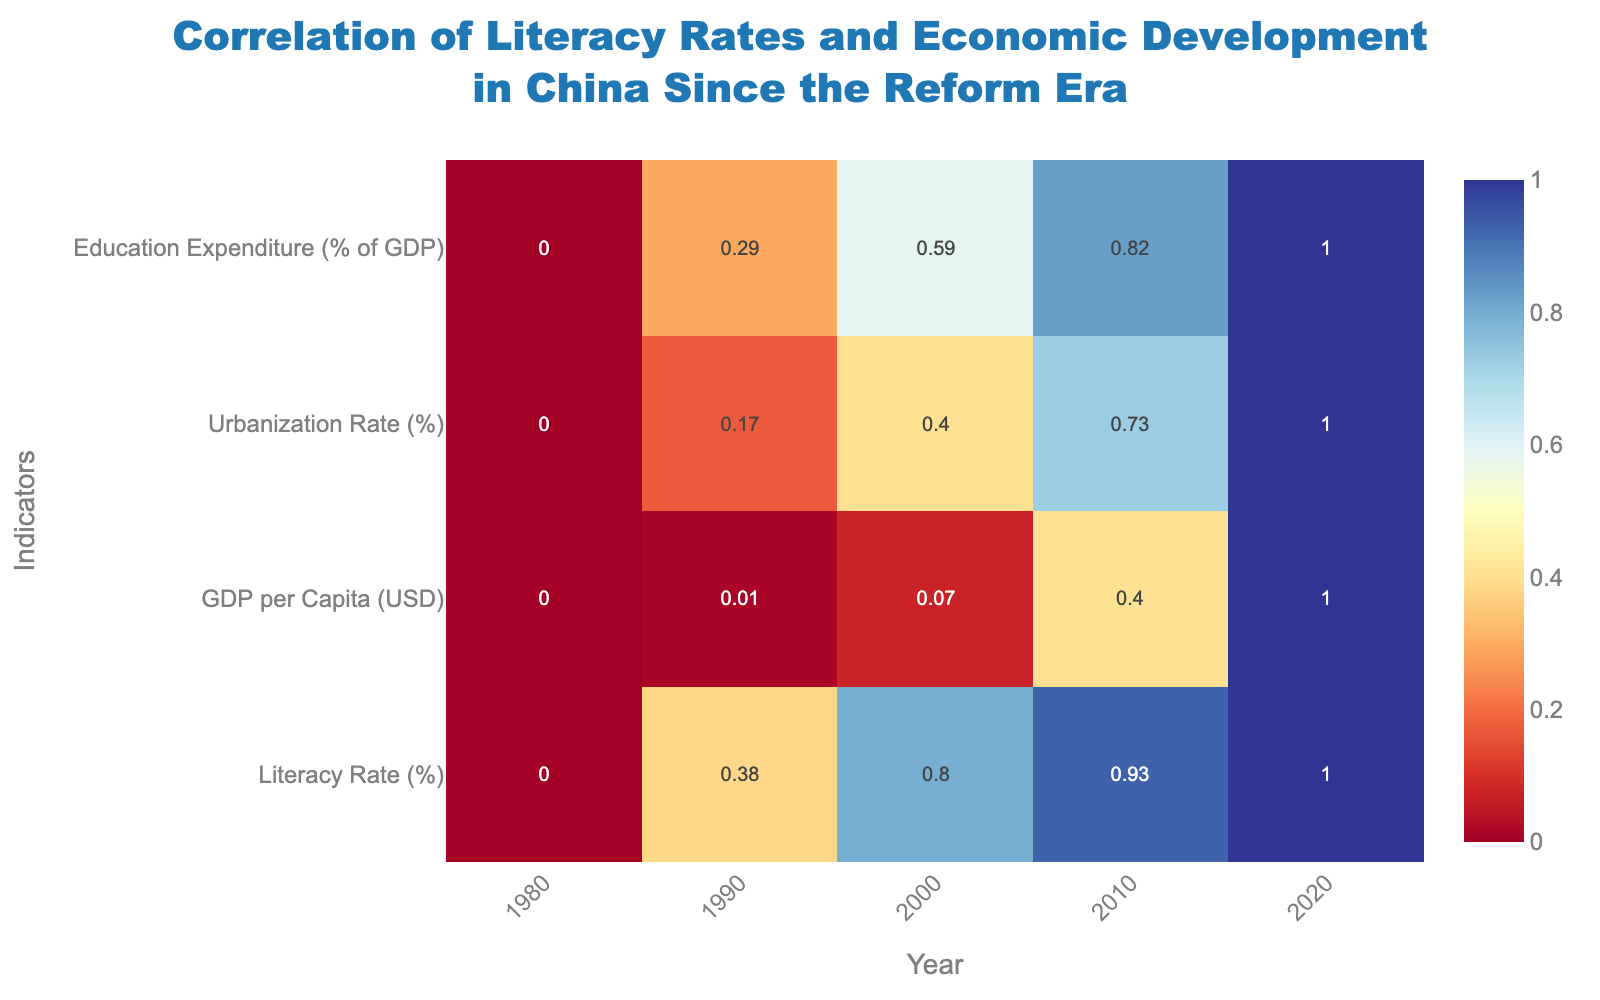what is the main title of the heatmap? Look at the top portion of the heatmap where titles are generally placed. The main title reads, "Correlation of Literacy Rates and Economic Development in China Since the Reform Era".
Answer: Correlation of Literacy Rates and Economic Development in China Since the Reform Era What are the indicators shown on the y-axis? Examine the y-axis to determine which variables are listed. The y-axis indicators are Literacy Rate (%), GDP per Capita (USD), Urbanization Rate (%), and Education Expenditure (% of GDP).
Answer: Literacy Rate (%), GDP per Capita (USD), Urbanization Rate (%), Education Expenditure (% of GDP) Which year had the highest normalized value for education expenditure? Locate the indicators on the y-axis and find "Education Expenditure (% of GDP)". Move horizontally across each cell in this row to identify the highest value. The year 2020 has the highest normalized value.
Answer: 2020 What is the trend of literacy rates from 1980 to 2020? Observe the "Literacy Rate (%)" row and follow how the colors change from 1980 to 2020. The trend shows an increase in the normalized value as the colors transition from lighter to darker shades.
Answer: Increasing How does the urbanization rate in 2000 compare to that in 1990? Look at the row corresponding to "Urbanization Rate (%)" and compare the values for the years 1990 and 2000. The normalized value for 2000 is higher than that of 1990, indicating an increase in urbanization.
Answer: 2000 urbanization rate is higher than 1990 What is the relationship between GDP per capita and literacy rate over the years? Observe the trends in both rows "GDP per Capita (USD)" and "Literacy Rate (%)". Both indicators show an increasing trend from 1980 to 2020, suggesting a positive correlation.
Answer: Positive correlation Which year shows a significant increase in GDP per capita compared to the previous decade? Examine the "GDP per Capita (USD)" row. Compare normalized values decade by decade. The year 2000 shows a significant increase in GDP per capita compared to 1990.
Answer: 2000 Which indicator exhibits the most consistent growth over the years? For each indicator, observe the color transitions from 1980 to 2020. The "Literacy Rate (%)" shows a consistent increase, with uniformly darker shades over the years.
Answer: Literacy Rate (%) Between which years does the education expenditure see the least growth? Look at the "Education Expenditure (% of GDP)" row and compare color changes between each pair of consecutive years. The color change between 2010 and 2020 is minimal compared to other intervals, indicating the least growth.
Answer: 2010 to 2020 